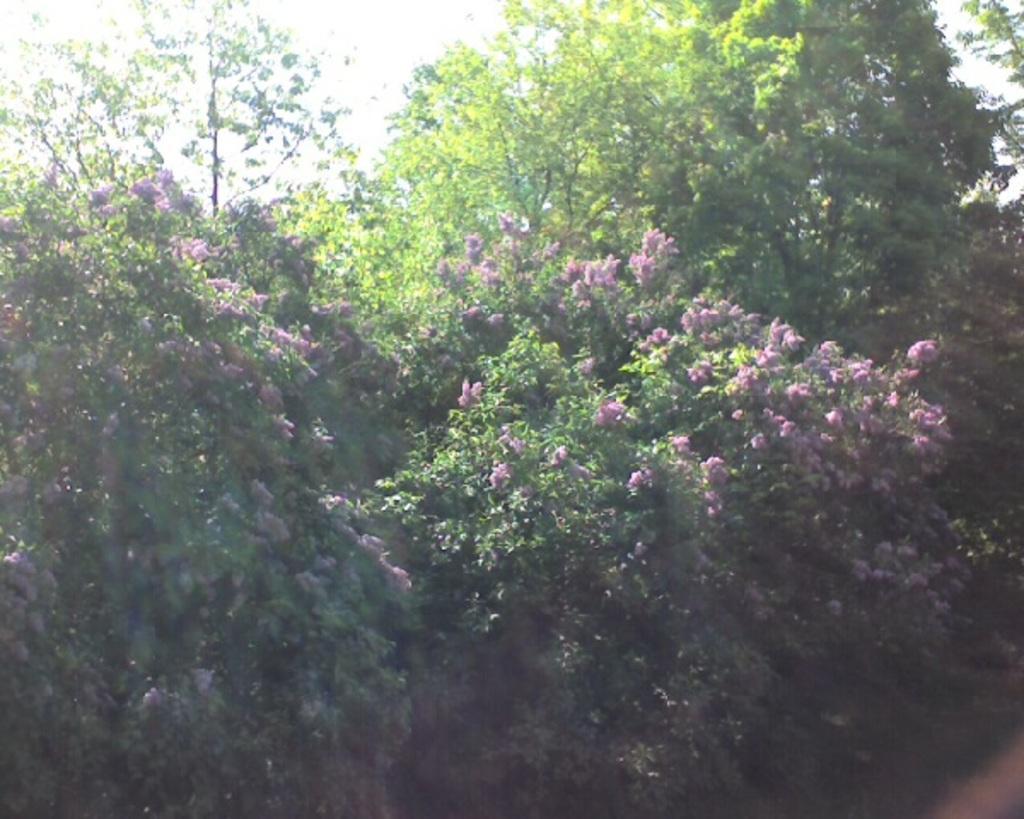Please provide a concise description of this image. In this image there are plants. There are flowers to the plants. At the top there is the sky. 